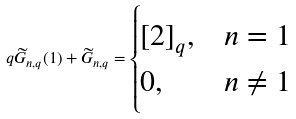Convert formula to latex. <formula><loc_0><loc_0><loc_500><loc_500>q { \widetilde { G } _ { n , q } ( 1 ) } + { \widetilde { G } _ { n , q } } = \begin{cases} [ 2 ] _ { q } , & n = 1 \\ 0 , & n \ne 1 \end{cases}</formula> 